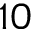Convert formula to latex. <formula><loc_0><loc_0><loc_500><loc_500>1 0</formula> 